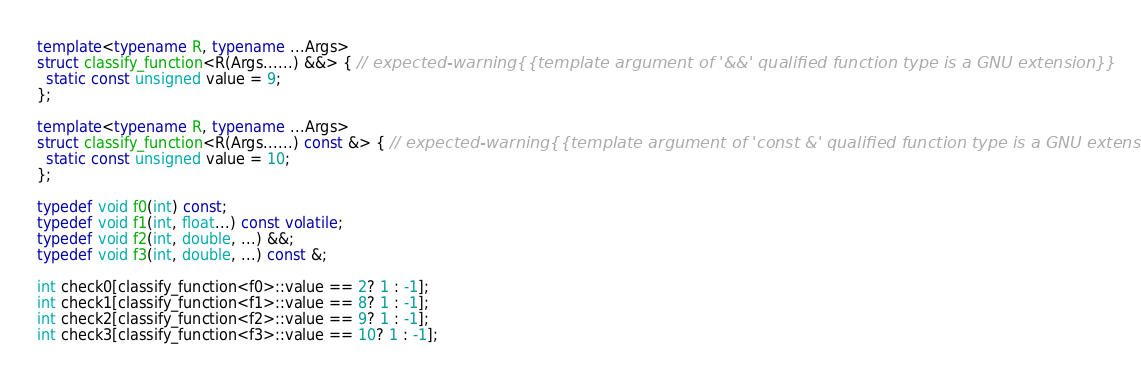Convert code to text. <code><loc_0><loc_0><loc_500><loc_500><_C++_>
template<typename R, typename ...Args>
struct classify_function<R(Args......) &&> { // expected-warning{{template argument of '&&' qualified function type is a GNU extension}}
  static const unsigned value = 9;
};

template<typename R, typename ...Args>
struct classify_function<R(Args......) const &> { // expected-warning{{template argument of 'const &' qualified function type is a GNU extension}}
  static const unsigned value = 10;
};

typedef void f0(int) const;
typedef void f1(int, float...) const volatile;
typedef void f2(int, double, ...) &&;
typedef void f3(int, double, ...) const &;

int check0[classify_function<f0>::value == 2? 1 : -1];
int check1[classify_function<f1>::value == 8? 1 : -1];
int check2[classify_function<f2>::value == 9? 1 : -1];
int check3[classify_function<f3>::value == 10? 1 : -1];
</code> 